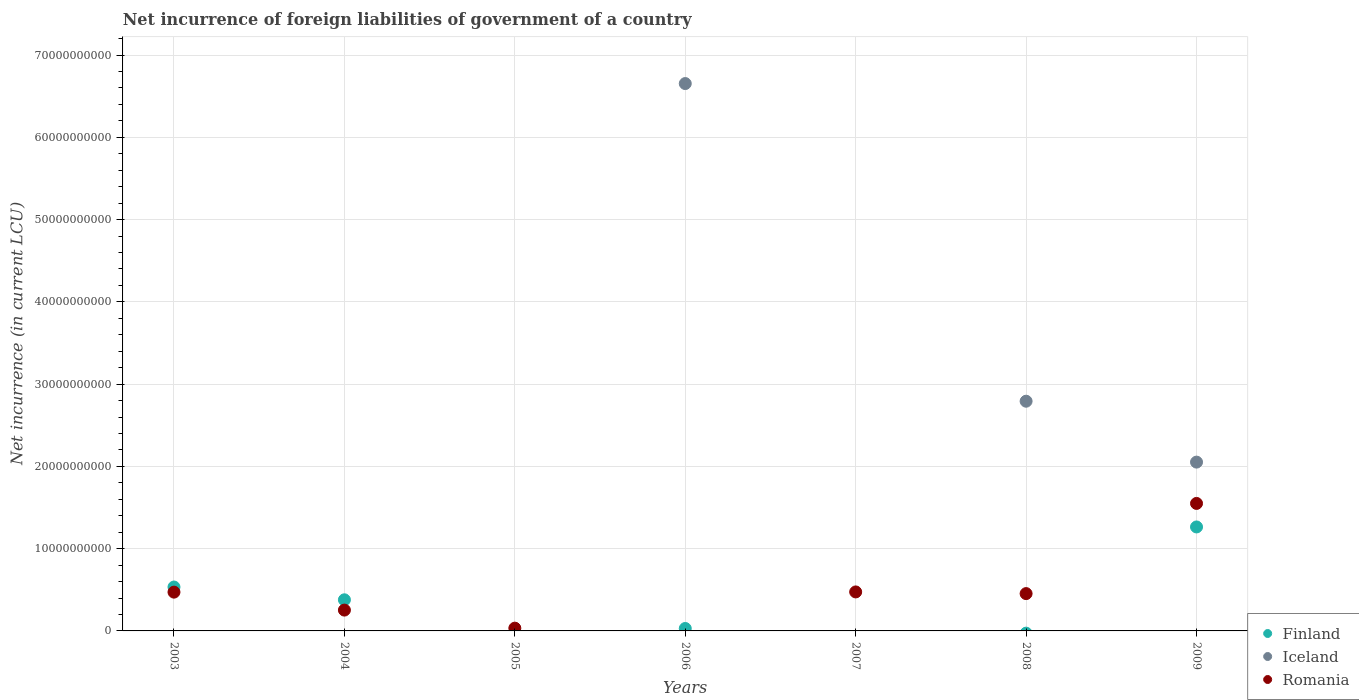Is the number of dotlines equal to the number of legend labels?
Your answer should be compact. No. What is the net incurrence of foreign liabilities in Finland in 2006?
Keep it short and to the point. 2.96e+08. Across all years, what is the maximum net incurrence of foreign liabilities in Romania?
Your answer should be compact. 1.55e+1. In which year was the net incurrence of foreign liabilities in Iceland maximum?
Provide a succinct answer. 2006. What is the total net incurrence of foreign liabilities in Iceland in the graph?
Give a very brief answer. 1.15e+11. What is the difference between the net incurrence of foreign liabilities in Finland in 2006 and that in 2009?
Offer a very short reply. -1.23e+1. What is the difference between the net incurrence of foreign liabilities in Iceland in 2006 and the net incurrence of foreign liabilities in Romania in 2008?
Offer a very short reply. 6.20e+1. What is the average net incurrence of foreign liabilities in Romania per year?
Your response must be concise. 4.62e+09. In the year 2009, what is the difference between the net incurrence of foreign liabilities in Finland and net incurrence of foreign liabilities in Iceland?
Offer a terse response. -7.88e+09. What is the ratio of the net incurrence of foreign liabilities in Finland in 2006 to that in 2009?
Your response must be concise. 0.02. What is the difference between the highest and the second highest net incurrence of foreign liabilities in Iceland?
Keep it short and to the point. 3.86e+1. What is the difference between the highest and the lowest net incurrence of foreign liabilities in Romania?
Your answer should be very brief. 1.55e+1. Does the net incurrence of foreign liabilities in Romania monotonically increase over the years?
Ensure brevity in your answer.  No. How many dotlines are there?
Offer a terse response. 3. How many years are there in the graph?
Give a very brief answer. 7. Where does the legend appear in the graph?
Offer a terse response. Bottom right. How many legend labels are there?
Your response must be concise. 3. How are the legend labels stacked?
Offer a very short reply. Vertical. What is the title of the graph?
Ensure brevity in your answer.  Net incurrence of foreign liabilities of government of a country. Does "Cuba" appear as one of the legend labels in the graph?
Provide a succinct answer. No. What is the label or title of the Y-axis?
Offer a very short reply. Net incurrence (in current LCU). What is the Net incurrence (in current LCU) in Finland in 2003?
Provide a short and direct response. 5.34e+09. What is the Net incurrence (in current LCU) of Romania in 2003?
Make the answer very short. 4.71e+09. What is the Net incurrence (in current LCU) in Finland in 2004?
Keep it short and to the point. 3.78e+09. What is the Net incurrence (in current LCU) of Iceland in 2004?
Provide a short and direct response. 0. What is the Net incurrence (in current LCU) in Romania in 2004?
Ensure brevity in your answer.  2.53e+09. What is the Net incurrence (in current LCU) of Finland in 2005?
Offer a very short reply. 0. What is the Net incurrence (in current LCU) of Iceland in 2005?
Give a very brief answer. 0. What is the Net incurrence (in current LCU) of Romania in 2005?
Offer a terse response. 3.37e+08. What is the Net incurrence (in current LCU) of Finland in 2006?
Offer a very short reply. 2.96e+08. What is the Net incurrence (in current LCU) of Iceland in 2006?
Provide a short and direct response. 6.65e+1. What is the Net incurrence (in current LCU) in Iceland in 2007?
Your answer should be compact. 0. What is the Net incurrence (in current LCU) of Romania in 2007?
Give a very brief answer. 4.74e+09. What is the Net incurrence (in current LCU) in Iceland in 2008?
Your answer should be very brief. 2.79e+1. What is the Net incurrence (in current LCU) in Romania in 2008?
Your answer should be very brief. 4.54e+09. What is the Net incurrence (in current LCU) of Finland in 2009?
Your answer should be very brief. 1.26e+1. What is the Net incurrence (in current LCU) in Iceland in 2009?
Give a very brief answer. 2.05e+1. What is the Net incurrence (in current LCU) of Romania in 2009?
Your answer should be very brief. 1.55e+1. Across all years, what is the maximum Net incurrence (in current LCU) in Finland?
Make the answer very short. 1.26e+1. Across all years, what is the maximum Net incurrence (in current LCU) of Iceland?
Provide a succinct answer. 6.65e+1. Across all years, what is the maximum Net incurrence (in current LCU) in Romania?
Ensure brevity in your answer.  1.55e+1. What is the total Net incurrence (in current LCU) in Finland in the graph?
Provide a short and direct response. 2.21e+1. What is the total Net incurrence (in current LCU) in Iceland in the graph?
Offer a very short reply. 1.15e+11. What is the total Net incurrence (in current LCU) in Romania in the graph?
Provide a succinct answer. 3.24e+1. What is the difference between the Net incurrence (in current LCU) in Finland in 2003 and that in 2004?
Offer a terse response. 1.55e+09. What is the difference between the Net incurrence (in current LCU) of Romania in 2003 and that in 2004?
Give a very brief answer. 2.18e+09. What is the difference between the Net incurrence (in current LCU) of Romania in 2003 and that in 2005?
Your answer should be compact. 4.38e+09. What is the difference between the Net incurrence (in current LCU) of Finland in 2003 and that in 2006?
Keep it short and to the point. 5.04e+09. What is the difference between the Net incurrence (in current LCU) in Romania in 2003 and that in 2007?
Make the answer very short. -2.50e+07. What is the difference between the Net incurrence (in current LCU) of Romania in 2003 and that in 2008?
Make the answer very short. 1.78e+08. What is the difference between the Net incurrence (in current LCU) in Finland in 2003 and that in 2009?
Ensure brevity in your answer.  -7.30e+09. What is the difference between the Net incurrence (in current LCU) of Romania in 2003 and that in 2009?
Offer a terse response. -1.08e+1. What is the difference between the Net incurrence (in current LCU) of Romania in 2004 and that in 2005?
Ensure brevity in your answer.  2.19e+09. What is the difference between the Net incurrence (in current LCU) of Finland in 2004 and that in 2006?
Keep it short and to the point. 3.49e+09. What is the difference between the Net incurrence (in current LCU) of Romania in 2004 and that in 2007?
Ensure brevity in your answer.  -2.21e+09. What is the difference between the Net incurrence (in current LCU) in Romania in 2004 and that in 2008?
Make the answer very short. -2.00e+09. What is the difference between the Net incurrence (in current LCU) of Finland in 2004 and that in 2009?
Ensure brevity in your answer.  -8.85e+09. What is the difference between the Net incurrence (in current LCU) in Romania in 2004 and that in 2009?
Your answer should be compact. -1.30e+1. What is the difference between the Net incurrence (in current LCU) of Romania in 2005 and that in 2007?
Your answer should be very brief. -4.40e+09. What is the difference between the Net incurrence (in current LCU) in Romania in 2005 and that in 2008?
Keep it short and to the point. -4.20e+09. What is the difference between the Net incurrence (in current LCU) in Romania in 2005 and that in 2009?
Your answer should be compact. -1.52e+1. What is the difference between the Net incurrence (in current LCU) of Iceland in 2006 and that in 2008?
Ensure brevity in your answer.  3.86e+1. What is the difference between the Net incurrence (in current LCU) of Finland in 2006 and that in 2009?
Provide a short and direct response. -1.23e+1. What is the difference between the Net incurrence (in current LCU) of Iceland in 2006 and that in 2009?
Offer a terse response. 4.60e+1. What is the difference between the Net incurrence (in current LCU) of Romania in 2007 and that in 2008?
Offer a terse response. 2.03e+08. What is the difference between the Net incurrence (in current LCU) of Romania in 2007 and that in 2009?
Your answer should be very brief. -1.08e+1. What is the difference between the Net incurrence (in current LCU) of Iceland in 2008 and that in 2009?
Your answer should be very brief. 7.40e+09. What is the difference between the Net incurrence (in current LCU) of Romania in 2008 and that in 2009?
Provide a succinct answer. -1.10e+1. What is the difference between the Net incurrence (in current LCU) in Finland in 2003 and the Net incurrence (in current LCU) in Romania in 2004?
Ensure brevity in your answer.  2.80e+09. What is the difference between the Net incurrence (in current LCU) in Finland in 2003 and the Net incurrence (in current LCU) in Romania in 2005?
Make the answer very short. 5.00e+09. What is the difference between the Net incurrence (in current LCU) in Finland in 2003 and the Net incurrence (in current LCU) in Iceland in 2006?
Provide a short and direct response. -6.12e+1. What is the difference between the Net incurrence (in current LCU) in Finland in 2003 and the Net incurrence (in current LCU) in Romania in 2007?
Give a very brief answer. 5.96e+08. What is the difference between the Net incurrence (in current LCU) in Finland in 2003 and the Net incurrence (in current LCU) in Iceland in 2008?
Offer a very short reply. -2.26e+1. What is the difference between the Net incurrence (in current LCU) in Finland in 2003 and the Net incurrence (in current LCU) in Romania in 2008?
Make the answer very short. 7.99e+08. What is the difference between the Net incurrence (in current LCU) of Finland in 2003 and the Net incurrence (in current LCU) of Iceland in 2009?
Your response must be concise. -1.52e+1. What is the difference between the Net incurrence (in current LCU) of Finland in 2003 and the Net incurrence (in current LCU) of Romania in 2009?
Offer a terse response. -1.02e+1. What is the difference between the Net incurrence (in current LCU) of Finland in 2004 and the Net incurrence (in current LCU) of Romania in 2005?
Keep it short and to the point. 3.45e+09. What is the difference between the Net incurrence (in current LCU) in Finland in 2004 and the Net incurrence (in current LCU) in Iceland in 2006?
Provide a short and direct response. -6.27e+1. What is the difference between the Net incurrence (in current LCU) in Finland in 2004 and the Net incurrence (in current LCU) in Romania in 2007?
Your response must be concise. -9.56e+08. What is the difference between the Net incurrence (in current LCU) in Finland in 2004 and the Net incurrence (in current LCU) in Iceland in 2008?
Make the answer very short. -2.41e+1. What is the difference between the Net incurrence (in current LCU) of Finland in 2004 and the Net incurrence (in current LCU) of Romania in 2008?
Give a very brief answer. -7.53e+08. What is the difference between the Net incurrence (in current LCU) of Finland in 2004 and the Net incurrence (in current LCU) of Iceland in 2009?
Your answer should be very brief. -1.67e+1. What is the difference between the Net incurrence (in current LCU) of Finland in 2004 and the Net incurrence (in current LCU) of Romania in 2009?
Offer a terse response. -1.17e+1. What is the difference between the Net incurrence (in current LCU) of Finland in 2006 and the Net incurrence (in current LCU) of Romania in 2007?
Offer a very short reply. -4.44e+09. What is the difference between the Net incurrence (in current LCU) of Iceland in 2006 and the Net incurrence (in current LCU) of Romania in 2007?
Provide a succinct answer. 6.18e+1. What is the difference between the Net incurrence (in current LCU) in Finland in 2006 and the Net incurrence (in current LCU) in Iceland in 2008?
Ensure brevity in your answer.  -2.76e+1. What is the difference between the Net incurrence (in current LCU) of Finland in 2006 and the Net incurrence (in current LCU) of Romania in 2008?
Offer a very short reply. -4.24e+09. What is the difference between the Net incurrence (in current LCU) of Iceland in 2006 and the Net incurrence (in current LCU) of Romania in 2008?
Your answer should be very brief. 6.20e+1. What is the difference between the Net incurrence (in current LCU) of Finland in 2006 and the Net incurrence (in current LCU) of Iceland in 2009?
Offer a terse response. -2.02e+1. What is the difference between the Net incurrence (in current LCU) of Finland in 2006 and the Net incurrence (in current LCU) of Romania in 2009?
Keep it short and to the point. -1.52e+1. What is the difference between the Net incurrence (in current LCU) in Iceland in 2006 and the Net incurrence (in current LCU) in Romania in 2009?
Provide a succinct answer. 5.10e+1. What is the difference between the Net incurrence (in current LCU) in Iceland in 2008 and the Net incurrence (in current LCU) in Romania in 2009?
Your response must be concise. 1.24e+1. What is the average Net incurrence (in current LCU) of Finland per year?
Make the answer very short. 3.15e+09. What is the average Net incurrence (in current LCU) in Iceland per year?
Keep it short and to the point. 1.64e+1. What is the average Net incurrence (in current LCU) of Romania per year?
Your response must be concise. 4.62e+09. In the year 2003, what is the difference between the Net incurrence (in current LCU) in Finland and Net incurrence (in current LCU) in Romania?
Give a very brief answer. 6.21e+08. In the year 2004, what is the difference between the Net incurrence (in current LCU) in Finland and Net incurrence (in current LCU) in Romania?
Ensure brevity in your answer.  1.25e+09. In the year 2006, what is the difference between the Net incurrence (in current LCU) in Finland and Net incurrence (in current LCU) in Iceland?
Make the answer very short. -6.62e+1. In the year 2008, what is the difference between the Net incurrence (in current LCU) of Iceland and Net incurrence (in current LCU) of Romania?
Your answer should be very brief. 2.34e+1. In the year 2009, what is the difference between the Net incurrence (in current LCU) of Finland and Net incurrence (in current LCU) of Iceland?
Make the answer very short. -7.88e+09. In the year 2009, what is the difference between the Net incurrence (in current LCU) of Finland and Net incurrence (in current LCU) of Romania?
Offer a very short reply. -2.86e+09. In the year 2009, what is the difference between the Net incurrence (in current LCU) in Iceland and Net incurrence (in current LCU) in Romania?
Your response must be concise. 5.02e+09. What is the ratio of the Net incurrence (in current LCU) in Finland in 2003 to that in 2004?
Provide a short and direct response. 1.41. What is the ratio of the Net incurrence (in current LCU) of Romania in 2003 to that in 2004?
Give a very brief answer. 1.86. What is the ratio of the Net incurrence (in current LCU) in Romania in 2003 to that in 2005?
Your answer should be very brief. 14.01. What is the ratio of the Net incurrence (in current LCU) of Finland in 2003 to that in 2006?
Your response must be concise. 18.02. What is the ratio of the Net incurrence (in current LCU) in Romania in 2003 to that in 2007?
Your answer should be compact. 0.99. What is the ratio of the Net incurrence (in current LCU) in Romania in 2003 to that in 2008?
Give a very brief answer. 1.04. What is the ratio of the Net incurrence (in current LCU) of Finland in 2003 to that in 2009?
Your answer should be very brief. 0.42. What is the ratio of the Net incurrence (in current LCU) in Romania in 2003 to that in 2009?
Provide a succinct answer. 0.3. What is the ratio of the Net incurrence (in current LCU) of Romania in 2004 to that in 2005?
Your answer should be compact. 7.52. What is the ratio of the Net incurrence (in current LCU) of Finland in 2004 to that in 2006?
Your response must be concise. 12.78. What is the ratio of the Net incurrence (in current LCU) of Romania in 2004 to that in 2007?
Offer a terse response. 0.53. What is the ratio of the Net incurrence (in current LCU) in Romania in 2004 to that in 2008?
Offer a very short reply. 0.56. What is the ratio of the Net incurrence (in current LCU) of Finland in 2004 to that in 2009?
Your answer should be compact. 0.3. What is the ratio of the Net incurrence (in current LCU) in Romania in 2004 to that in 2009?
Make the answer very short. 0.16. What is the ratio of the Net incurrence (in current LCU) of Romania in 2005 to that in 2007?
Provide a short and direct response. 0.07. What is the ratio of the Net incurrence (in current LCU) of Romania in 2005 to that in 2008?
Offer a very short reply. 0.07. What is the ratio of the Net incurrence (in current LCU) in Romania in 2005 to that in 2009?
Ensure brevity in your answer.  0.02. What is the ratio of the Net incurrence (in current LCU) in Iceland in 2006 to that in 2008?
Provide a short and direct response. 2.38. What is the ratio of the Net incurrence (in current LCU) in Finland in 2006 to that in 2009?
Give a very brief answer. 0.02. What is the ratio of the Net incurrence (in current LCU) in Iceland in 2006 to that in 2009?
Your response must be concise. 3.24. What is the ratio of the Net incurrence (in current LCU) of Romania in 2007 to that in 2008?
Give a very brief answer. 1.04. What is the ratio of the Net incurrence (in current LCU) in Romania in 2007 to that in 2009?
Keep it short and to the point. 0.31. What is the ratio of the Net incurrence (in current LCU) in Iceland in 2008 to that in 2009?
Your answer should be compact. 1.36. What is the ratio of the Net incurrence (in current LCU) in Romania in 2008 to that in 2009?
Keep it short and to the point. 0.29. What is the difference between the highest and the second highest Net incurrence (in current LCU) in Finland?
Make the answer very short. 7.30e+09. What is the difference between the highest and the second highest Net incurrence (in current LCU) of Iceland?
Offer a terse response. 3.86e+1. What is the difference between the highest and the second highest Net incurrence (in current LCU) of Romania?
Provide a short and direct response. 1.08e+1. What is the difference between the highest and the lowest Net incurrence (in current LCU) of Finland?
Your answer should be compact. 1.26e+1. What is the difference between the highest and the lowest Net incurrence (in current LCU) of Iceland?
Offer a very short reply. 6.65e+1. What is the difference between the highest and the lowest Net incurrence (in current LCU) in Romania?
Your answer should be very brief. 1.55e+1. 